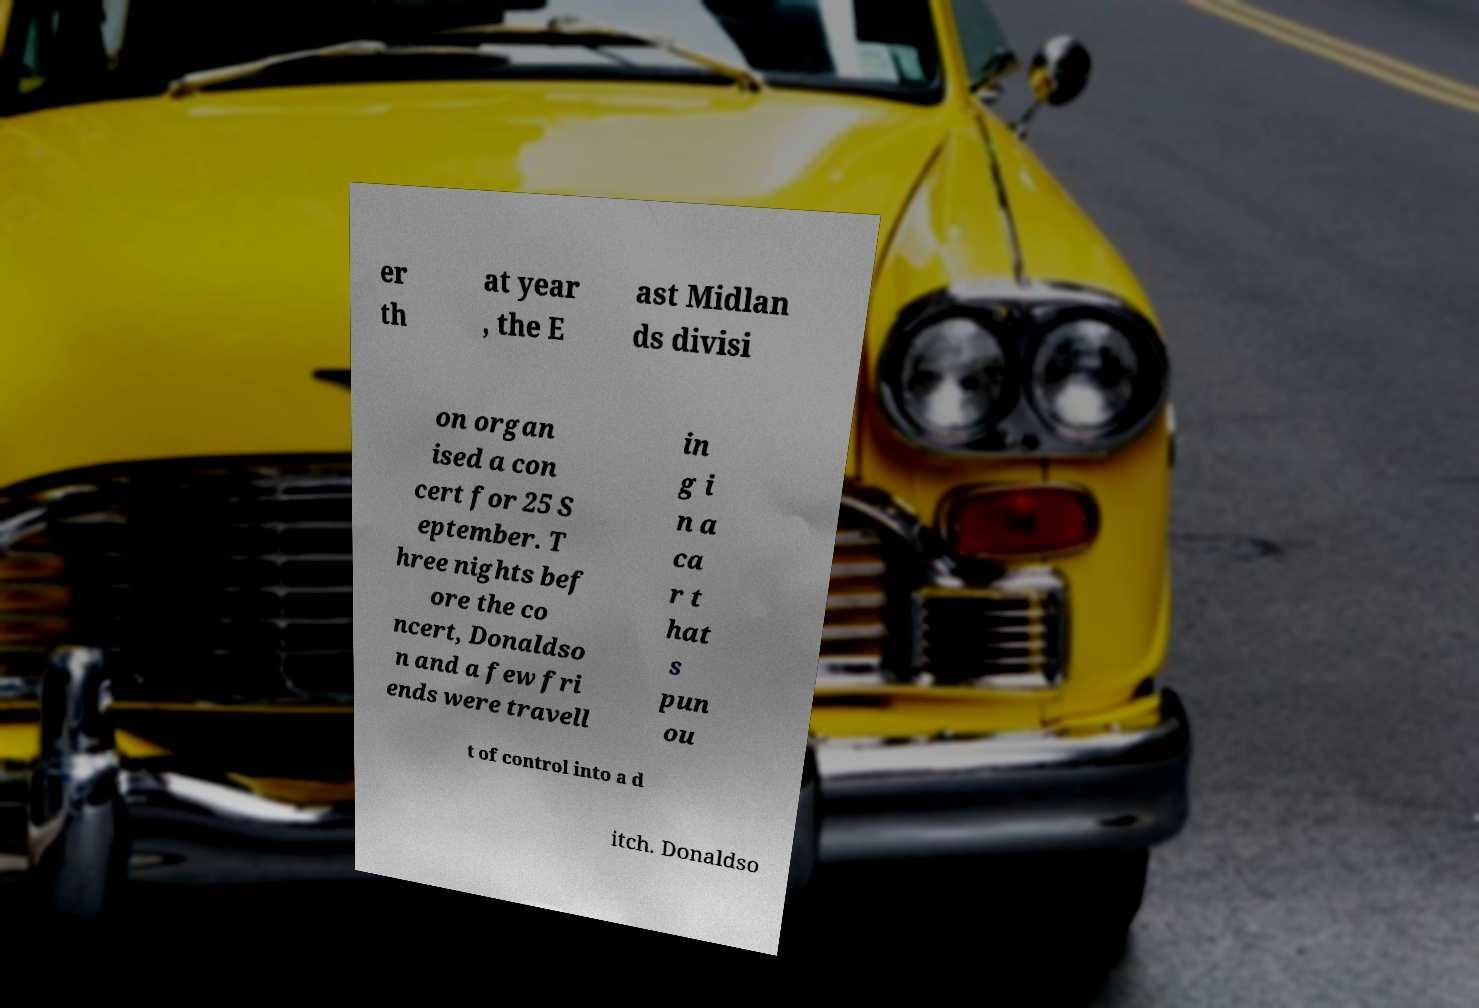Please read and relay the text visible in this image. What does it say? er th at year , the E ast Midlan ds divisi on organ ised a con cert for 25 S eptember. T hree nights bef ore the co ncert, Donaldso n and a few fri ends were travell in g i n a ca r t hat s pun ou t of control into a d itch. Donaldso 